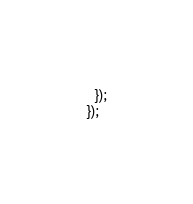Convert code to text. <code><loc_0><loc_0><loc_500><loc_500><_TypeScript_>  });
});
</code> 